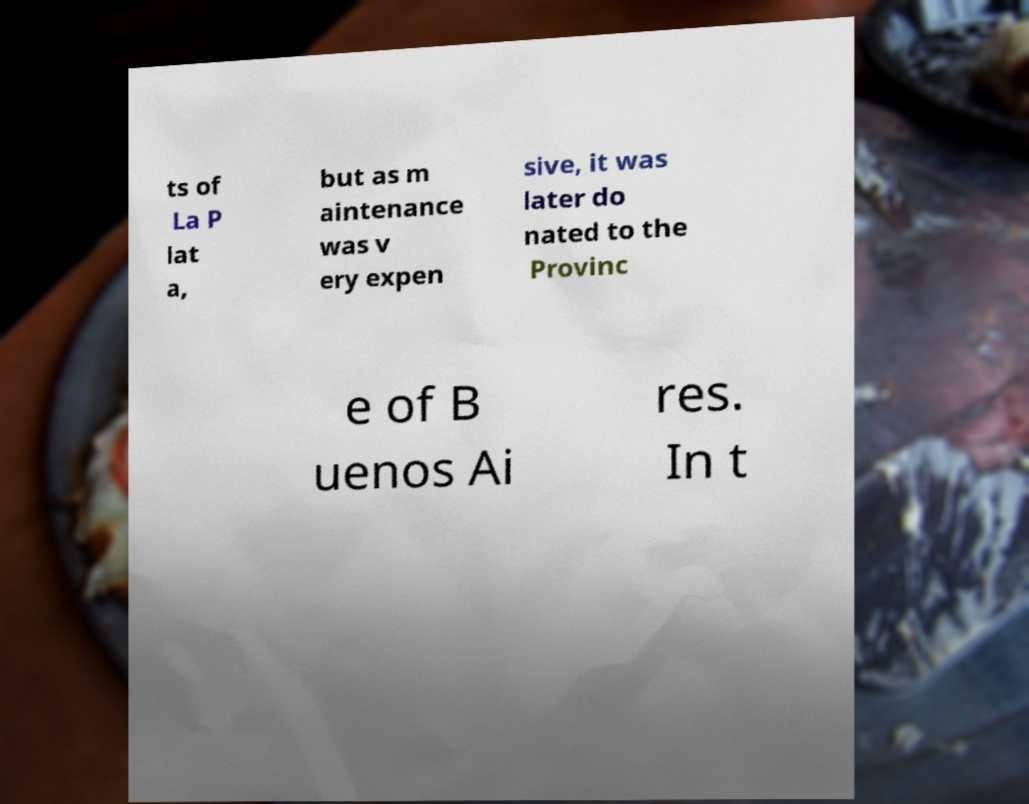For documentation purposes, I need the text within this image transcribed. Could you provide that? ts of La P lat a, but as m aintenance was v ery expen sive, it was later do nated to the Provinc e of B uenos Ai res. In t 